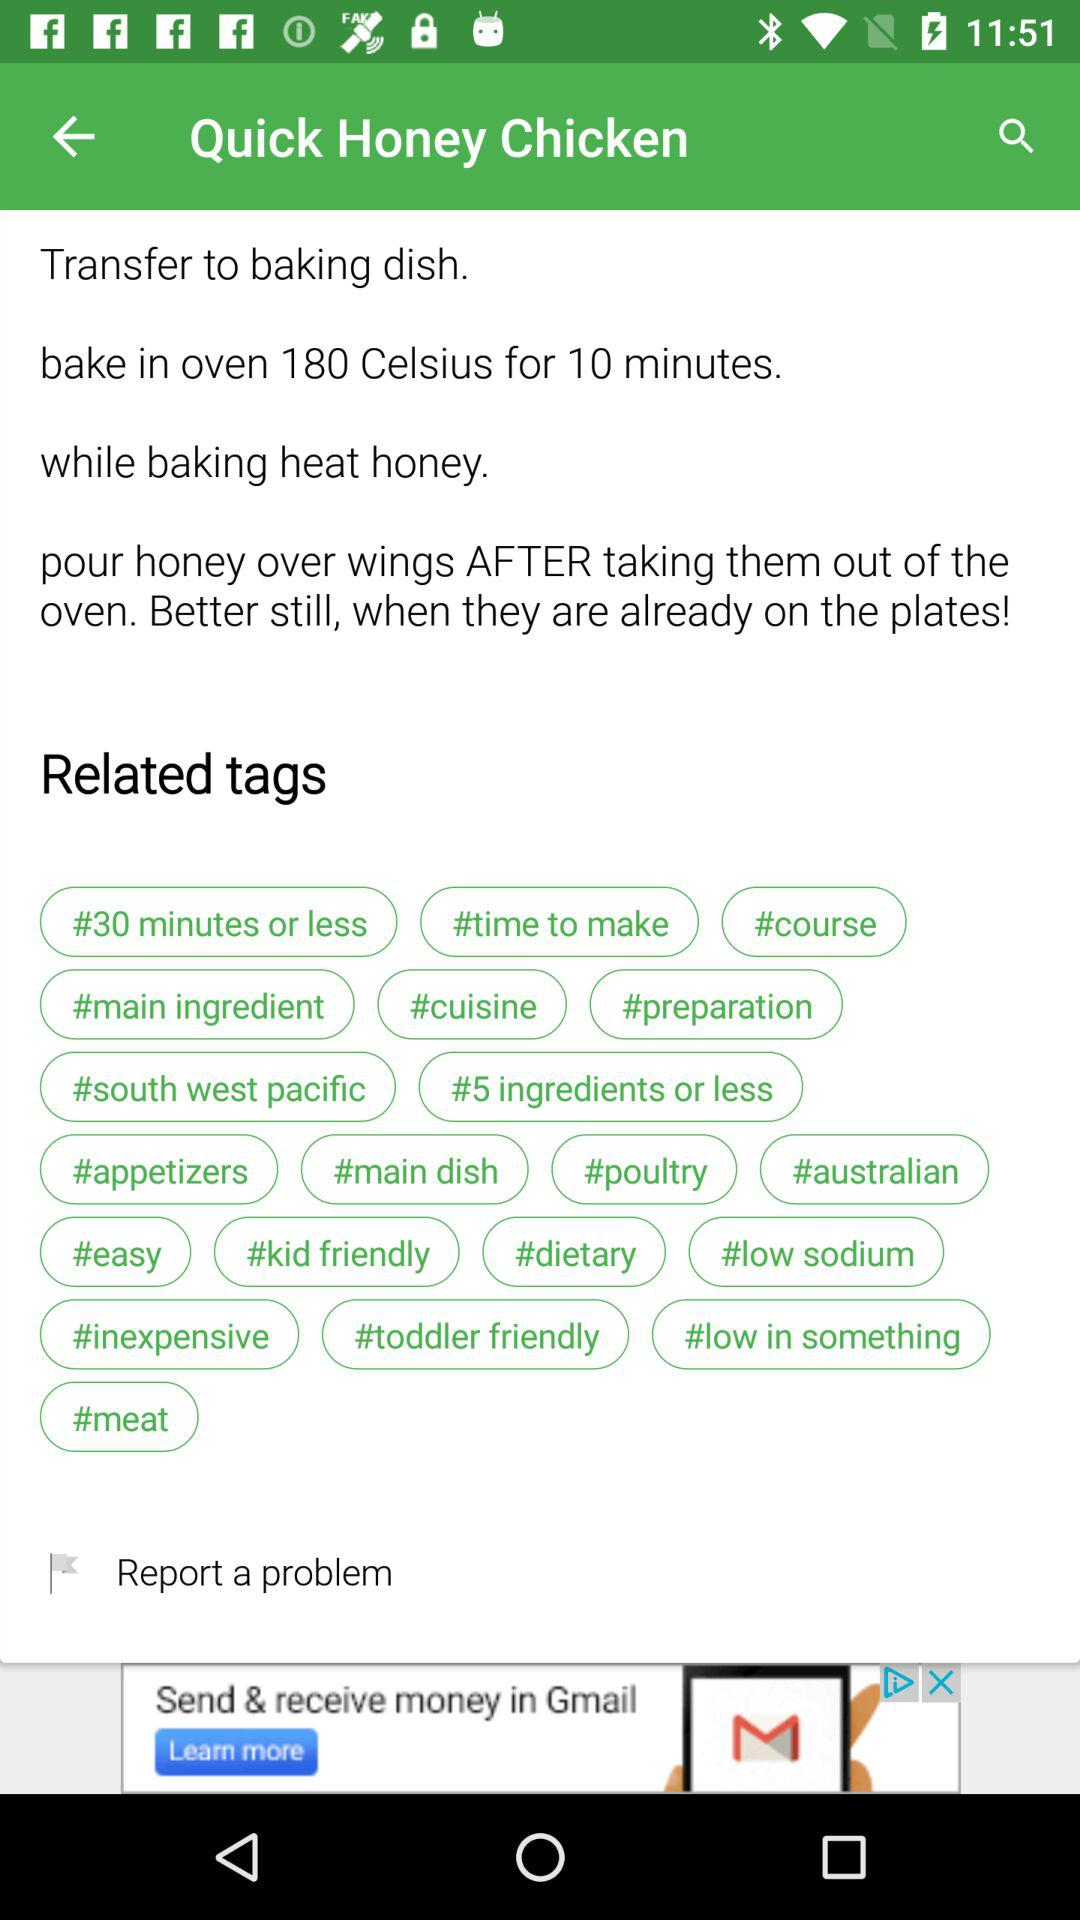What are the related tags? The related tags are "#30 minutes or less", "#time to make", "#course", "#main ingredient", "#cuisine", "#preparation", "#south west pacific", "#5 ingredients or less", "#appetizers", "#main dish", "#poultry", "#australian", "#easy", "#kid friendly", "#dietary", "#low sodium", "#inexpensive", "#toddler friendly", "#low in something" and "#meat". 